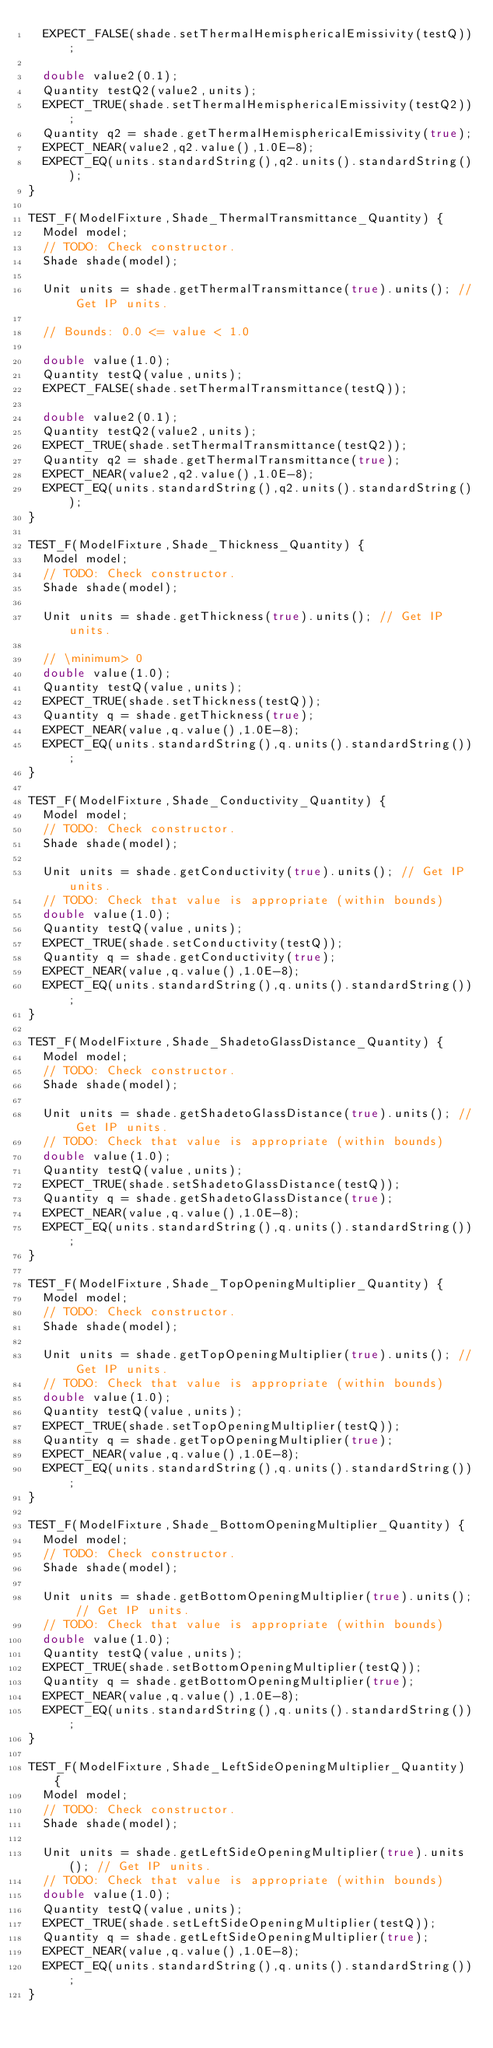Convert code to text. <code><loc_0><loc_0><loc_500><loc_500><_C++_>  EXPECT_FALSE(shade.setThermalHemisphericalEmissivity(testQ));

  double value2(0.1);
  Quantity testQ2(value2,units);
  EXPECT_TRUE(shade.setThermalHemisphericalEmissivity(testQ2));
  Quantity q2 = shade.getThermalHemisphericalEmissivity(true);
  EXPECT_NEAR(value2,q2.value(),1.0E-8);
  EXPECT_EQ(units.standardString(),q2.units().standardString());
}

TEST_F(ModelFixture,Shade_ThermalTransmittance_Quantity) {
  Model model;
  // TODO: Check constructor.
  Shade shade(model);

  Unit units = shade.getThermalTransmittance(true).units(); // Get IP units.

  // Bounds: 0.0 <= value < 1.0

  double value(1.0);
  Quantity testQ(value,units);
  EXPECT_FALSE(shade.setThermalTransmittance(testQ));

  double value2(0.1);
  Quantity testQ2(value2,units);
  EXPECT_TRUE(shade.setThermalTransmittance(testQ2));
  Quantity q2 = shade.getThermalTransmittance(true);
  EXPECT_NEAR(value2,q2.value(),1.0E-8);
  EXPECT_EQ(units.standardString(),q2.units().standardString());
}

TEST_F(ModelFixture,Shade_Thickness_Quantity) {
  Model model;
  // TODO: Check constructor.
  Shade shade(model);

  Unit units = shade.getThickness(true).units(); // Get IP units.

  // \minimum> 0
  double value(1.0);
  Quantity testQ(value,units);
  EXPECT_TRUE(shade.setThickness(testQ));
  Quantity q = shade.getThickness(true);
  EXPECT_NEAR(value,q.value(),1.0E-8);
  EXPECT_EQ(units.standardString(),q.units().standardString());
}

TEST_F(ModelFixture,Shade_Conductivity_Quantity) {
  Model model;
  // TODO: Check constructor.
  Shade shade(model);

  Unit units = shade.getConductivity(true).units(); // Get IP units.
  // TODO: Check that value is appropriate (within bounds)
  double value(1.0);
  Quantity testQ(value,units);
  EXPECT_TRUE(shade.setConductivity(testQ));
  Quantity q = shade.getConductivity(true);
  EXPECT_NEAR(value,q.value(),1.0E-8);
  EXPECT_EQ(units.standardString(),q.units().standardString());
}

TEST_F(ModelFixture,Shade_ShadetoGlassDistance_Quantity) {
  Model model;
  // TODO: Check constructor.
  Shade shade(model);

  Unit units = shade.getShadetoGlassDistance(true).units(); // Get IP units.
  // TODO: Check that value is appropriate (within bounds)
  double value(1.0);
  Quantity testQ(value,units);
  EXPECT_TRUE(shade.setShadetoGlassDistance(testQ));
  Quantity q = shade.getShadetoGlassDistance(true);
  EXPECT_NEAR(value,q.value(),1.0E-8);
  EXPECT_EQ(units.standardString(),q.units().standardString());
}

TEST_F(ModelFixture,Shade_TopOpeningMultiplier_Quantity) {
  Model model;
  // TODO: Check constructor.
  Shade shade(model);

  Unit units = shade.getTopOpeningMultiplier(true).units(); // Get IP units.
  // TODO: Check that value is appropriate (within bounds)
  double value(1.0);
  Quantity testQ(value,units);
  EXPECT_TRUE(shade.setTopOpeningMultiplier(testQ));
  Quantity q = shade.getTopOpeningMultiplier(true);
  EXPECT_NEAR(value,q.value(),1.0E-8);
  EXPECT_EQ(units.standardString(),q.units().standardString());
}

TEST_F(ModelFixture,Shade_BottomOpeningMultiplier_Quantity) {
  Model model;
  // TODO: Check constructor.
  Shade shade(model);

  Unit units = shade.getBottomOpeningMultiplier(true).units(); // Get IP units.
  // TODO: Check that value is appropriate (within bounds)
  double value(1.0);
  Quantity testQ(value,units);
  EXPECT_TRUE(shade.setBottomOpeningMultiplier(testQ));
  Quantity q = shade.getBottomOpeningMultiplier(true);
  EXPECT_NEAR(value,q.value(),1.0E-8);
  EXPECT_EQ(units.standardString(),q.units().standardString());
}

TEST_F(ModelFixture,Shade_LeftSideOpeningMultiplier_Quantity) {
  Model model;
  // TODO: Check constructor.
  Shade shade(model);

  Unit units = shade.getLeftSideOpeningMultiplier(true).units(); // Get IP units.
  // TODO: Check that value is appropriate (within bounds)
  double value(1.0);
  Quantity testQ(value,units);
  EXPECT_TRUE(shade.setLeftSideOpeningMultiplier(testQ));
  Quantity q = shade.getLeftSideOpeningMultiplier(true);
  EXPECT_NEAR(value,q.value(),1.0E-8);
  EXPECT_EQ(units.standardString(),q.units().standardString());
}
</code> 